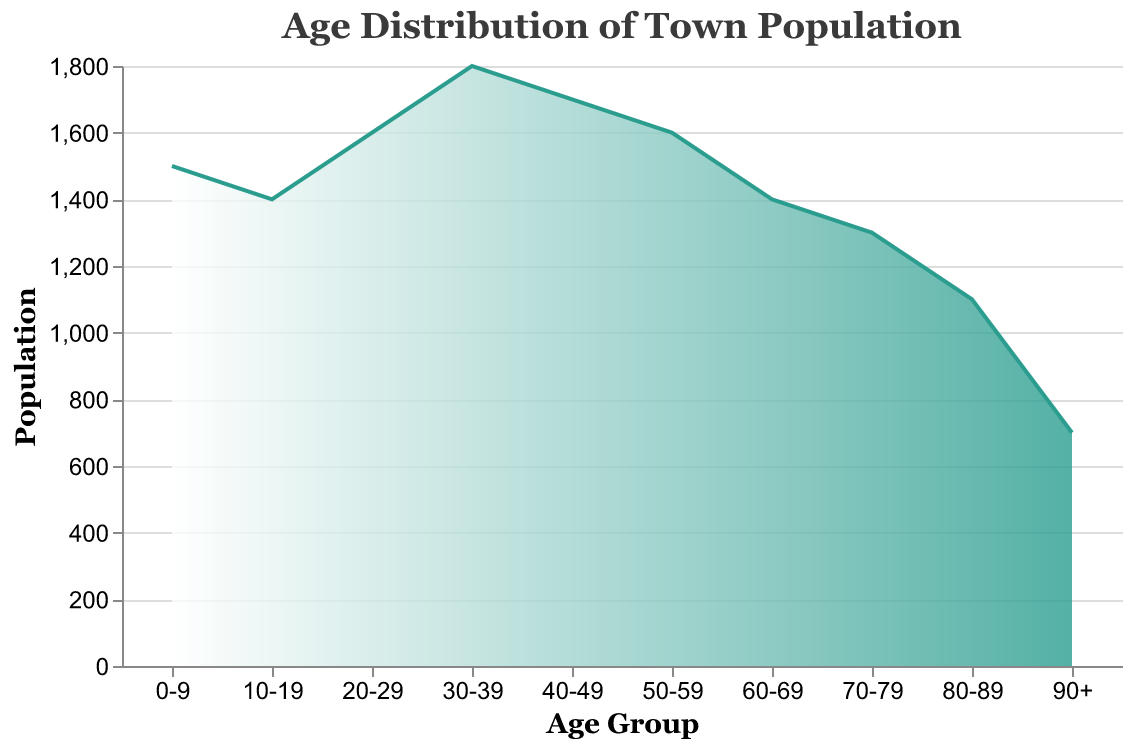what is the title of the plot? The title of the plot is given at the top of the figure, and it is "Age Distribution of Town Population".
Answer: Age Distribution of Town Population What is the color gradient used in the plot? The color gradient in the plot transitions from white to a greenish color. This is used in the area under the density plot.
Answer: white to green Which age group has the highest population? Looking at the peak of the density plot, the age group 30-39 shows the highest population count.
Answer: 30-39 How many age groups have a population of 1600? From the plot, we can see that the age groups 20-29 and 50-59 both have a population of 1600.
Answer: 2 Which two age groups have the same population count? Referring to the plot, the age groups 10-19 and 60-69 both have a population count of 1400.
Answer: 10-19 and 60-69 What is the total population of senior citizens (age 60 and above)? To find this, we sum the populations of the age groups 60-69, 70-79, 80-89, and 90+. (1400 + 1300 + 1100 + 700) = 4500.
Answer: 4500 Which age group has the lowest population? Observing the density plot, the age group 90+ has the lowest population count among all age groups.
Answer: 90+ What is the population difference between the age groups 30-39 and 80-89? By comparing the population numbers of these two age groups: 1800 - 1100 = 700.
Answer: 700 How does the population trend change as the age groups increase from 50-59 to 90+? Analyzing the density plot, the population consistently decreases as we move from the age groups 50-59 (1600) to 90+ (700).
Answer: decreases What visual element indicates the size of the population? The height of the area under the density plot corresponds to the population size for each age group. Taller areas represent larger populations.
Answer: height of the area 